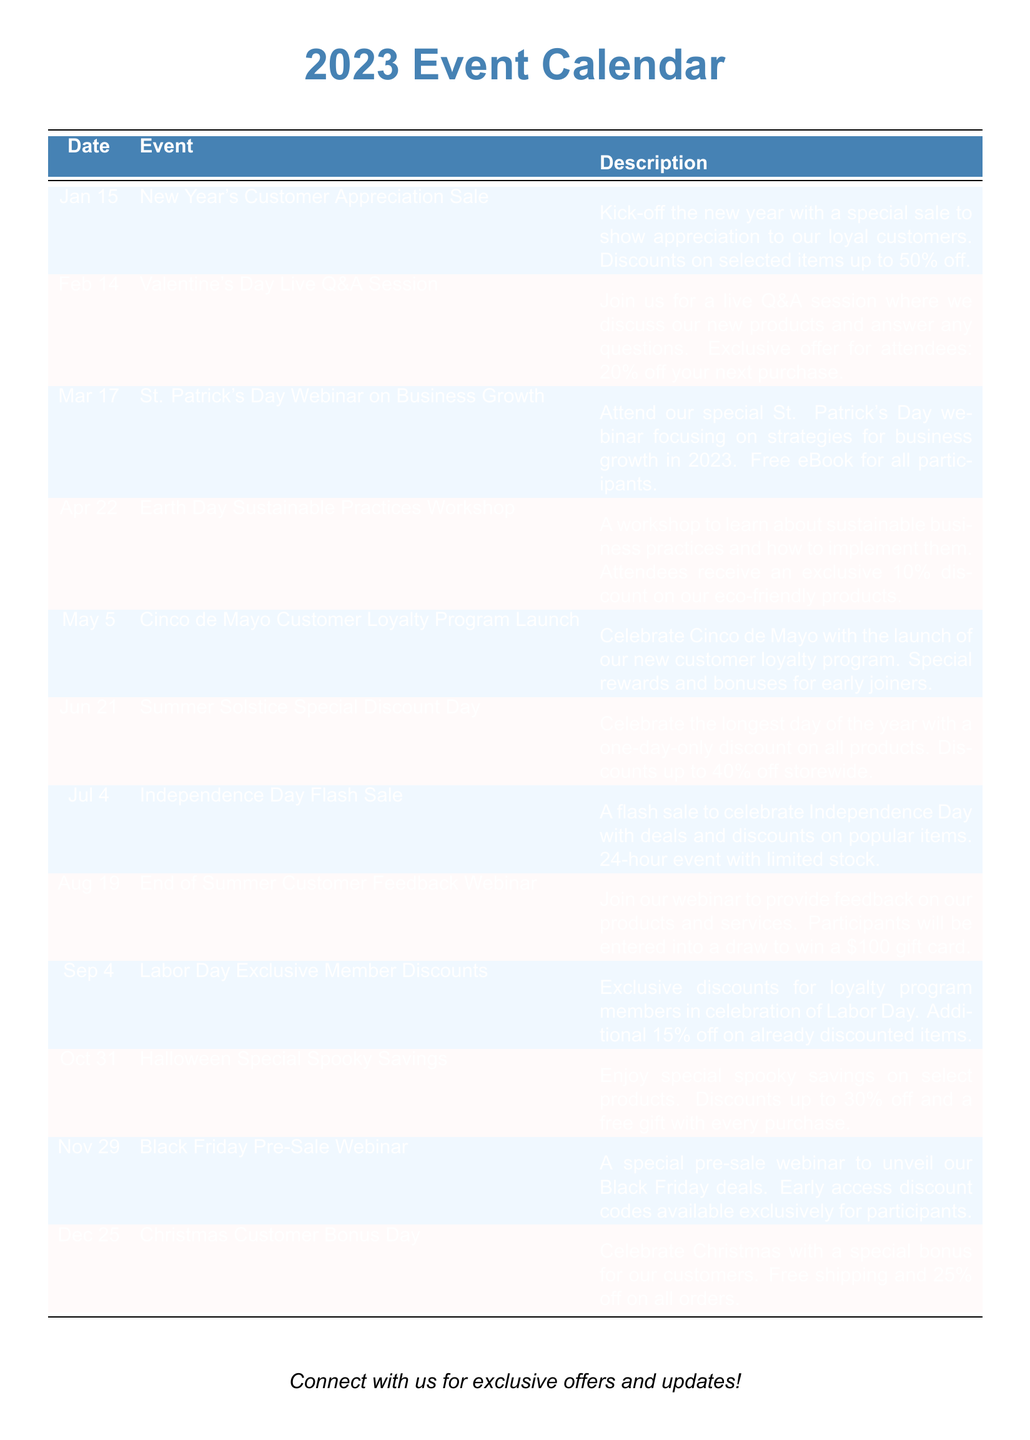What event is on January 15? The event listed for January 15 is the New Year's Customer Appreciation Sale.
Answer: New Year's Customer Appreciation Sale What discount is offered during the Valentine's Day event? The Valentine's Day Live Q&A Session offers an exclusive 20% off your next purchase for attendees.
Answer: 20% off Which month has the Earth Day workshop? The Earth Day Sustainable Practices Workshop is scheduled for April.
Answer: April How much is the discount during the Summer Solstice Special Discount Day? Discounts during the Summer Solstice Special Discount Day are up to 40% off storewide.
Answer: 40% off What is the exclusive offer for Labor Day? The exclusive offer for Labor Day includes an additional 15% off on already discounted items for loyalty program members.
Answer: Additional 15% off What type of event occurs on March 17? March 17 features a webinar on business growth strategies.
Answer: Webinar What reward is offered for participants of the End of Summer Customer Feedback Webinar? Participants of the End of Summer Customer Feedback Webinar will be entered into a draw to win a $100 gift card.
Answer: $100 gift card Which event occurs last in the calendar year? The last event in the calendar year is the Christmas Customer Bonus Day.
Answer: Christmas Customer Bonus Day What unique aspect is included in the Halloween event? The Halloween Special Spooky Savings includes a free gift with every purchase.
Answer: Free gift 